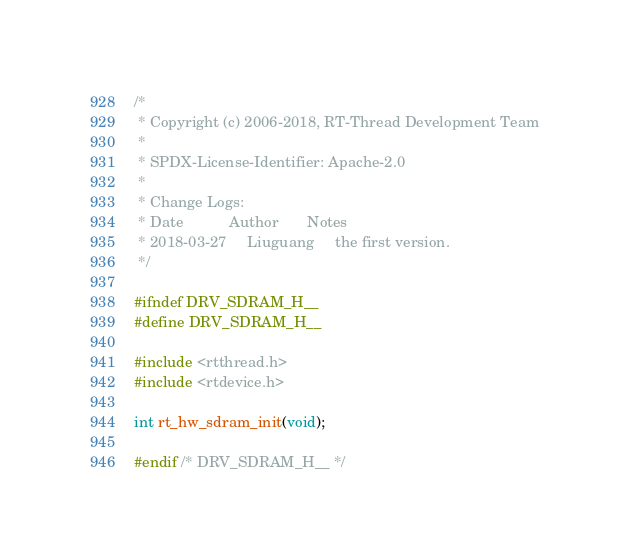<code> <loc_0><loc_0><loc_500><loc_500><_C_>/*
 * Copyright (c) 2006-2018, RT-Thread Development Team
 *
 * SPDX-License-Identifier: Apache-2.0
 *
 * Change Logs:
 * Date           Author       Notes
 * 2018-03-27     Liuguang     the first version.
 */
 
#ifndef DRV_SDRAM_H__
#define DRV_SDRAM_H__

#include <rtthread.h>
#include <rtdevice.h>

int rt_hw_sdram_init(void);

#endif /* DRV_SDRAM_H__ */
</code> 